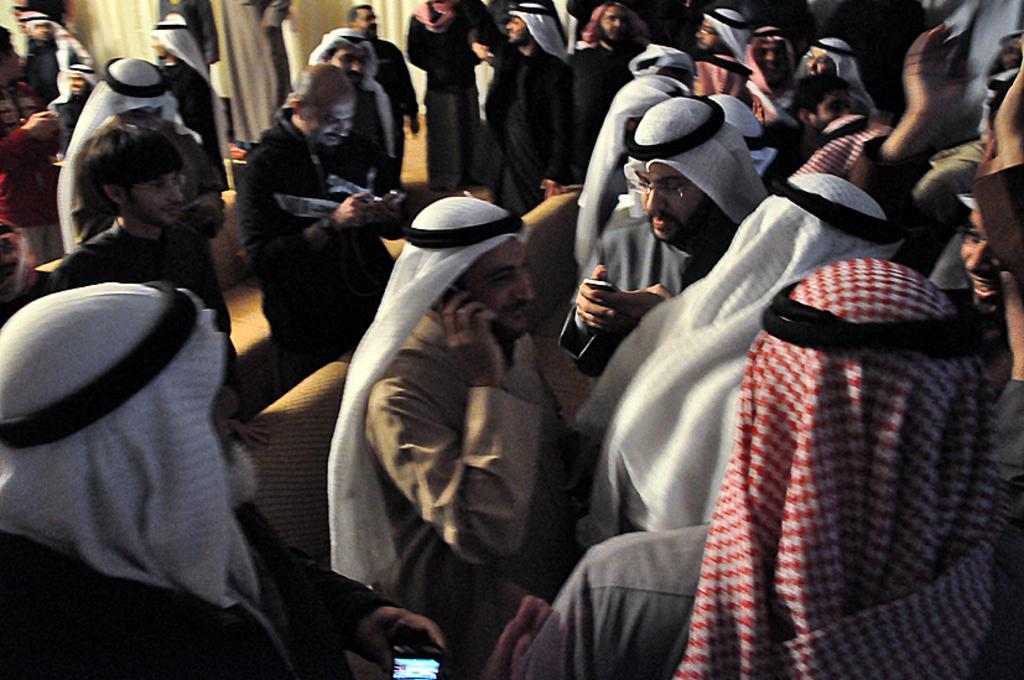How many people are in the image? There are people in the image, but the exact number is not specified. What are the people in the image doing? The people in the image are standing. What type of sand can be seen in the image? There is no sand present in the image. Who is the friend of the person standing in the image? The fact does not mention any specific person or their friends, so it is not possible to answer this question. 